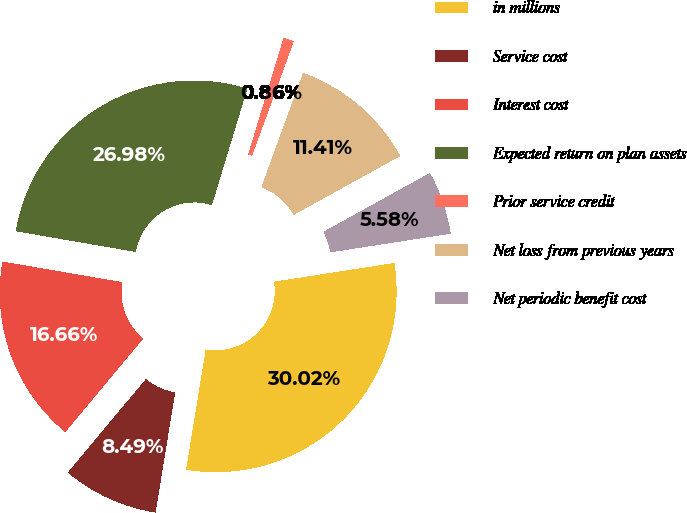Convert chart. <chart><loc_0><loc_0><loc_500><loc_500><pie_chart><fcel>in millions<fcel>Service cost<fcel>Interest cost<fcel>Expected return on plan assets<fcel>Prior service credit<fcel>Net loss from previous years<fcel>Net periodic benefit cost<nl><fcel>30.02%<fcel>8.49%<fcel>16.66%<fcel>26.98%<fcel>0.86%<fcel>11.41%<fcel>5.58%<nl></chart> 